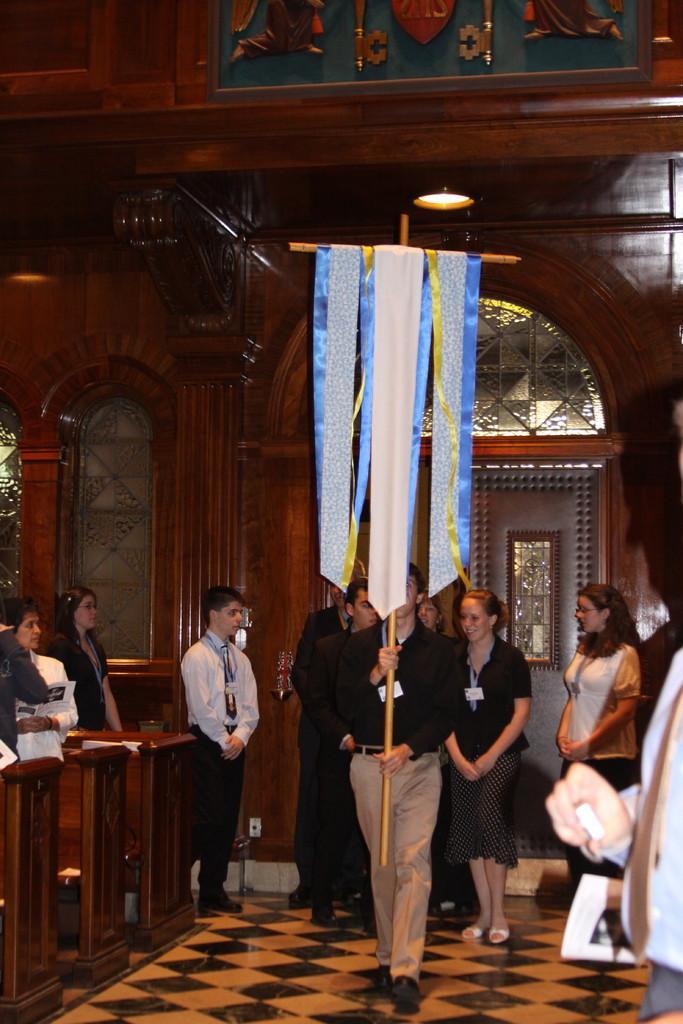Describe this image in one or two sentences. In this image I can see there are few people walking holding a cross and there are few persons standing at the left side of the benches. 